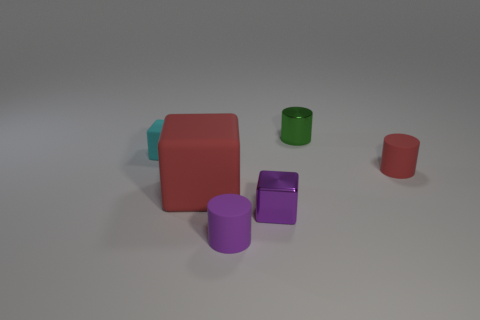Subtract all small matte cylinders. How many cylinders are left? 1 Add 4 yellow matte cylinders. How many objects exist? 10 Add 1 tiny cyan rubber objects. How many tiny cyan rubber objects exist? 2 Subtract 1 cyan cubes. How many objects are left? 5 Subtract all red matte things. Subtract all tiny shiny things. How many objects are left? 2 Add 4 tiny cyan matte blocks. How many tiny cyan matte blocks are left? 5 